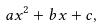<formula> <loc_0><loc_0><loc_500><loc_500>a x ^ { 2 } + b x + c ,</formula> 